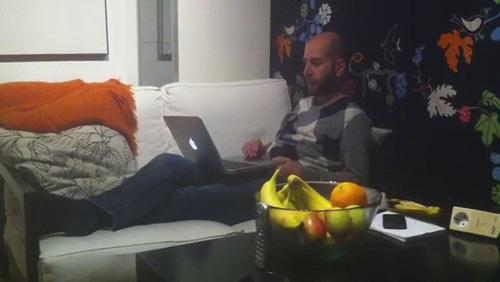State the position of the fruit bowl and the types of fruit within. The fruit bowl is on the black table, containing bananas and a part of an orange. What electronic devices can be found in this image, and where are they located? There is a silver Apple laptop on the man's lap, and a black cellphone is on the table next to some papers. Describe the actions and features of the man in the image. A bald man is sitting on a couch with his legs crossed, using a laptop. Explain the appearance of the couch and its cushions in the image. The couch is white with wooden armrests, and there are white sofa pillows on it. Can you provide a description of the wall art in the image? The wall features a colorful floral design. Express the scene involving the coffee table and its contents. A black coffee table holds a bowl of various fruits, a black cell phone on papers, and orange blanket with fray. Please describe the sweater worn by the man. The man is wearing a sweater with an argyle design. Describe the scene involving both the man and the couch he is sitting on. A bald man is sitting with his legs crossed on a white couch with wooden armrests, using a laptop. What is the man doing in the image, and what is he using? The man is sitting on a white couch with his legs crossed, using a silver Apple laptop on his lap. Provide a description of the blanket on the couch. The blanket on the couch is orange with frayed edges. Can you find the pink pillow on the floor? There is no mention of a pink pillow or a pillow on the floor in the image captions. There is a white cellphone on the table. The cellphone mentioned in the image is black, not white. There is a green and yellow striped blanket on the couch. The blanket on the couch is described as an orange throw, not green and yellow striped. Is the man wearing a blue hat? There is no mention of a hat, let alone a blue one, in the image captions. Is the wooden table bright red? The table mentioned in the image is described as being black, not red. Can you see the purple flowers in the fruit bowl? There is no mention of flowers in the fruit bowl; it is filled with various fruits instead. The wall has a large polka dot design. The design on the wall is described as a colorful floral design, not polka dots. The man is wearing a bright red shirt. The man's shirt is described as being gray, not red. Look for a green sofa in the picture. The sofa is described as being white, not green. Is there a computer with a blue logo on the man's lap? The laptop mentioned in the image is a silver Apple laptop with an Apple logo, not a blue logo. 